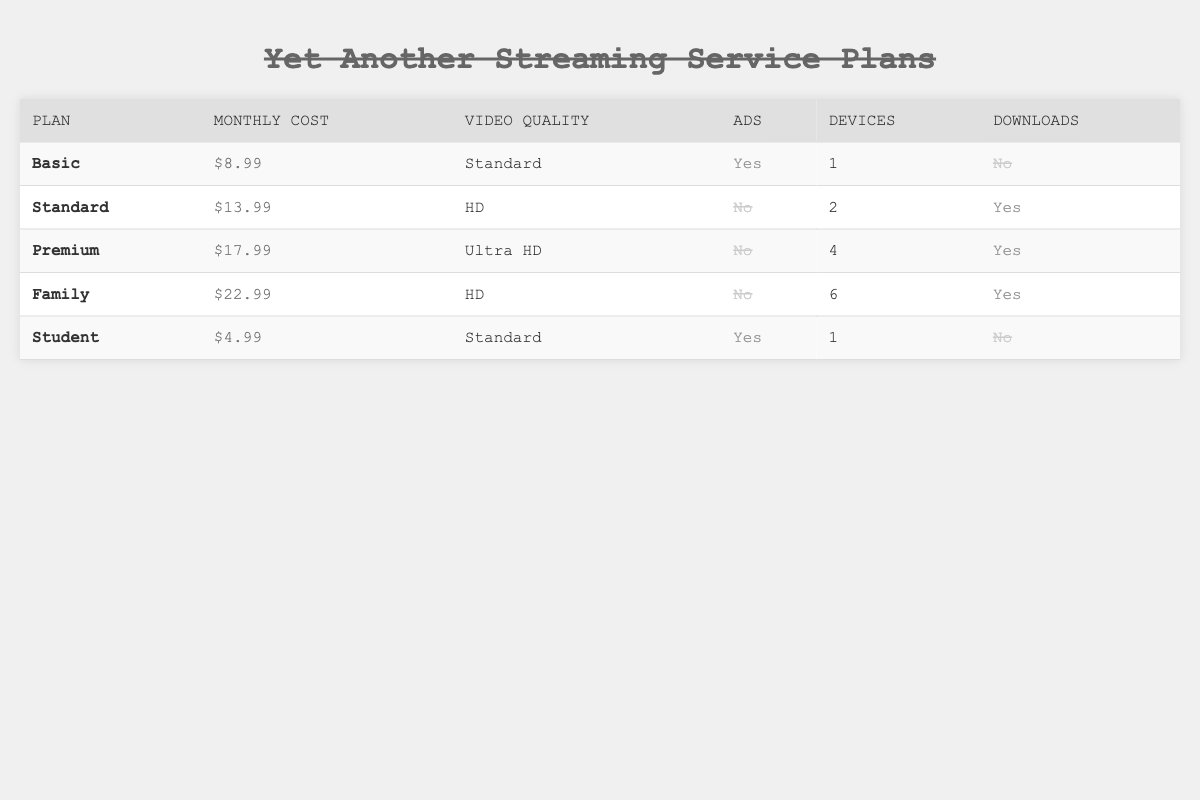What is the monthly cost of the Basic plan? The table lists the monthly cost of the Basic plan in the second row under the "Monthly Cost" column, which is $8.99.
Answer: $8.99 How many devices can be used with the Premium plan? The Premium plan is detailed in the third row, where the number of devices specified is 4.
Answer: 4 Is there a plan that allows offline downloads? By examining the table, I can see that both the Standard, Premium, and Family plans allow offline downloads, while the Basic and Student plans do not. Therefore, the answer is yes.
Answer: Yes What is the difference in monthly cost between the Family plan and the Student plan? The Family plan costs $22.99 and the Student plan costs $4.99. The difference is calculated as $22.99 - $4.99 = $18.00.
Answer: $18.00 Which plan has the highest video quality, and what is that quality? The table shows that the Premium plan has the highest video quality, which is Ultra HD, located in the third row under the "Video Quality" column.
Answer: Premium, Ultra HD How many plans include advertisements? Looking at the table, only the Basic and Student plans have advertisements. This totals to 2 plans.
Answer: 2 Which plan is the cheapest and what features does it include? The Student plan costs $4.99, which is the lowest. It includes Standard video quality, has ads, supports 1 device, and does not allow offline downloads.
Answer: Student plan, Standard video quality, ads, 1 device, no downloads What is the average monthly cost of all the plans? The monthly costs are $8.99, $13.99, $17.99, $22.99, and $4.99. To find the average, I first sum them: $8.99 + $13.99 + $17.99 + $22.99 + $4.99 = $68.95. Then, divide by the number of plans, which is 5, resulting in $68.95 / 5 = $13.79.
Answer: $13.79 How many plans have Standard video quality? The Basic and Student plans have Standard video quality according to the table. This gives a total of 2 plans with Standard quality.
Answer: 2 Which is the most expensive plan and does it require a contract? The Family plan at $22.99 is the most expensive. The data does not specify any contract terms, so I assume this detail is not included in the table. Thus, the answer to the second part is unknown.
Answer: Family, Unknown 